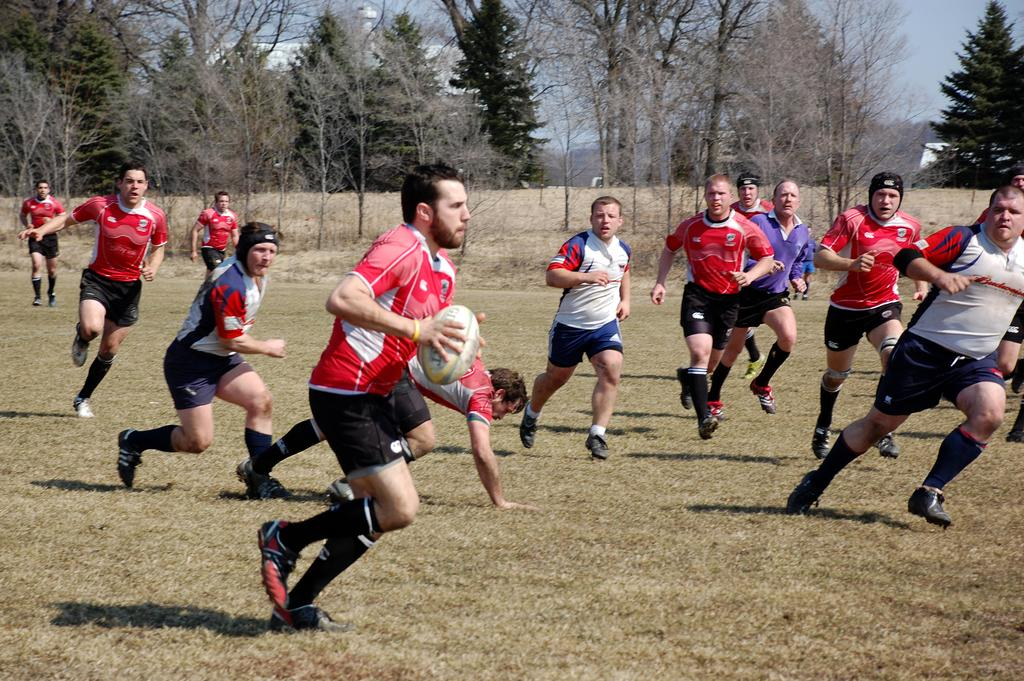What are the people in the image doing? The people in the image are running on the ground. What object is being held by one of the people in the image? There is a person holding a rugby ball in the image. What can be seen in the background of the image? Trees and the sky are visible in the background of the image. Can you tell me how many bees are buzzing around the rugby ball in the image? There are no bees present in the image; it features people running and holding a rugby ball. What type of beef is being cooked on the ground in the image? There is no beef or cooking activity present in the image. 